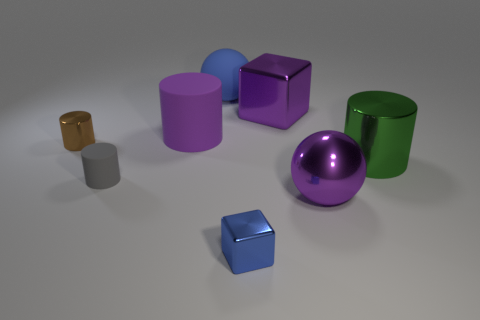Is there a purple object made of the same material as the big green object?
Make the answer very short. Yes. What is the color of the shiny object that is the same shape as the large blue rubber object?
Ensure brevity in your answer.  Purple. Is the number of purple cylinders that are in front of the metal ball less than the number of big green shiny things that are in front of the tiny gray rubber object?
Your answer should be very brief. No. What number of other things are the same shape as the big blue thing?
Your answer should be compact. 1. Is the number of gray rubber cylinders to the right of the big purple cube less than the number of large red rubber cubes?
Ensure brevity in your answer.  No. What is the material of the tiny object to the left of the tiny gray object?
Make the answer very short. Metal. How many other objects are there of the same size as the blue metal thing?
Offer a very short reply. 2. Are there fewer shiny cylinders than brown cylinders?
Keep it short and to the point. No. What is the shape of the tiny brown object?
Your answer should be very brief. Cylinder. Does the cube that is in front of the tiny gray rubber cylinder have the same color as the big rubber cylinder?
Provide a short and direct response. No. 